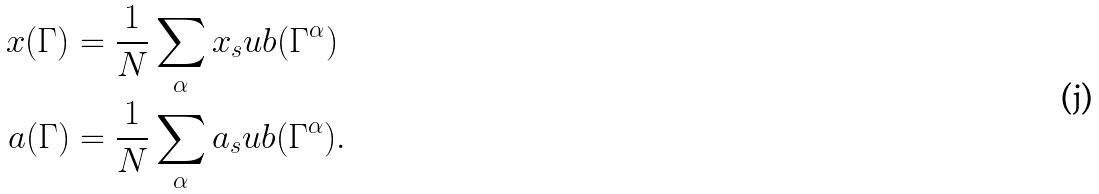<formula> <loc_0><loc_0><loc_500><loc_500>x ( \Gamma ) & = \frac { 1 } { N } \sum _ { \alpha } x _ { s } u b ( \Gamma ^ { \alpha } ) \\ a ( \Gamma ) & = \frac { 1 } { N } \sum _ { \alpha } a _ { s } u b ( \Gamma ^ { \alpha } ) .</formula> 